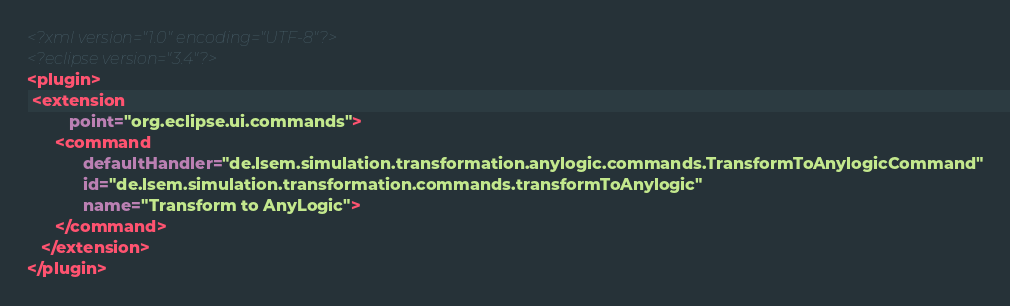Convert code to text. <code><loc_0><loc_0><loc_500><loc_500><_XML_><?xml version="1.0" encoding="UTF-8"?>
<?eclipse version="3.4"?>
<plugin>
 <extension
         point="org.eclipse.ui.commands">
      <command
            defaultHandler="de.lsem.simulation.transformation.anylogic.commands.TransformToAnylogicCommand"
            id="de.lsem.simulation.transformation.commands.transformToAnylogic"
            name="Transform to AnyLogic">
      </command>
   </extension>
</plugin>
</code> 